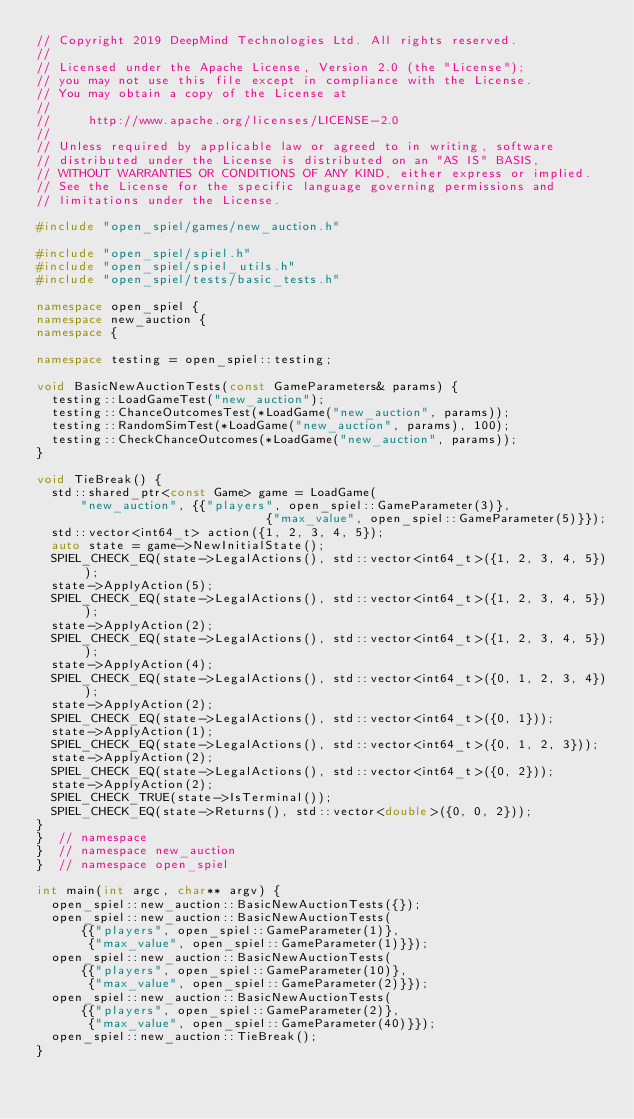Convert code to text. <code><loc_0><loc_0><loc_500><loc_500><_C++_>// Copyright 2019 DeepMind Technologies Ltd. All rights reserved.
//
// Licensed under the Apache License, Version 2.0 (the "License");
// you may not use this file except in compliance with the License.
// You may obtain a copy of the License at
//
//     http://www.apache.org/licenses/LICENSE-2.0
//
// Unless required by applicable law or agreed to in writing, software
// distributed under the License is distributed on an "AS IS" BASIS,
// WITHOUT WARRANTIES OR CONDITIONS OF ANY KIND, either express or implied.
// See the License for the specific language governing permissions and
// limitations under the License.

#include "open_spiel/games/new_auction.h"

#include "open_spiel/spiel.h"
#include "open_spiel/spiel_utils.h"
#include "open_spiel/tests/basic_tests.h"

namespace open_spiel {
namespace new_auction {
namespace {

namespace testing = open_spiel::testing;

void BasicNewAuctionTests(const GameParameters& params) {
  testing::LoadGameTest("new_auction");
  testing::ChanceOutcomesTest(*LoadGame("new_auction", params));
  testing::RandomSimTest(*LoadGame("new_auction", params), 100);
  testing::CheckChanceOutcomes(*LoadGame("new_auction", params));
}

void TieBreak() {
  std::shared_ptr<const Game> game = LoadGame(
      "new_auction", {{"players", open_spiel::GameParameter(3)},
                               {"max_value", open_spiel::GameParameter(5)}});
  std::vector<int64_t> action({1, 2, 3, 4, 5});
  auto state = game->NewInitialState();
  SPIEL_CHECK_EQ(state->LegalActions(), std::vector<int64_t>({1, 2, 3, 4, 5}));
  state->ApplyAction(5);
  SPIEL_CHECK_EQ(state->LegalActions(), std::vector<int64_t>({1, 2, 3, 4, 5}));
  state->ApplyAction(2);
  SPIEL_CHECK_EQ(state->LegalActions(), std::vector<int64_t>({1, 2, 3, 4, 5}));
  state->ApplyAction(4);
  SPIEL_CHECK_EQ(state->LegalActions(), std::vector<int64_t>({0, 1, 2, 3, 4}));
  state->ApplyAction(2);
  SPIEL_CHECK_EQ(state->LegalActions(), std::vector<int64_t>({0, 1}));
  state->ApplyAction(1);
  SPIEL_CHECK_EQ(state->LegalActions(), std::vector<int64_t>({0, 1, 2, 3}));
  state->ApplyAction(2);
  SPIEL_CHECK_EQ(state->LegalActions(), std::vector<int64_t>({0, 2}));
  state->ApplyAction(2);
  SPIEL_CHECK_TRUE(state->IsTerminal());
  SPIEL_CHECK_EQ(state->Returns(), std::vector<double>({0, 0, 2}));
}
}  // namespace
}  // namespace new_auction
}  // namespace open_spiel

int main(int argc, char** argv) {
  open_spiel::new_auction::BasicNewAuctionTests({});
  open_spiel::new_auction::BasicNewAuctionTests(
      {{"players", open_spiel::GameParameter(1)},
       {"max_value", open_spiel::GameParameter(1)}});
  open_spiel::new_auction::BasicNewAuctionTests(
      {{"players", open_spiel::GameParameter(10)},
       {"max_value", open_spiel::GameParameter(2)}});
  open_spiel::new_auction::BasicNewAuctionTests(
      {{"players", open_spiel::GameParameter(2)},
       {"max_value", open_spiel::GameParameter(40)}});
  open_spiel::new_auction::TieBreak();
}
</code> 